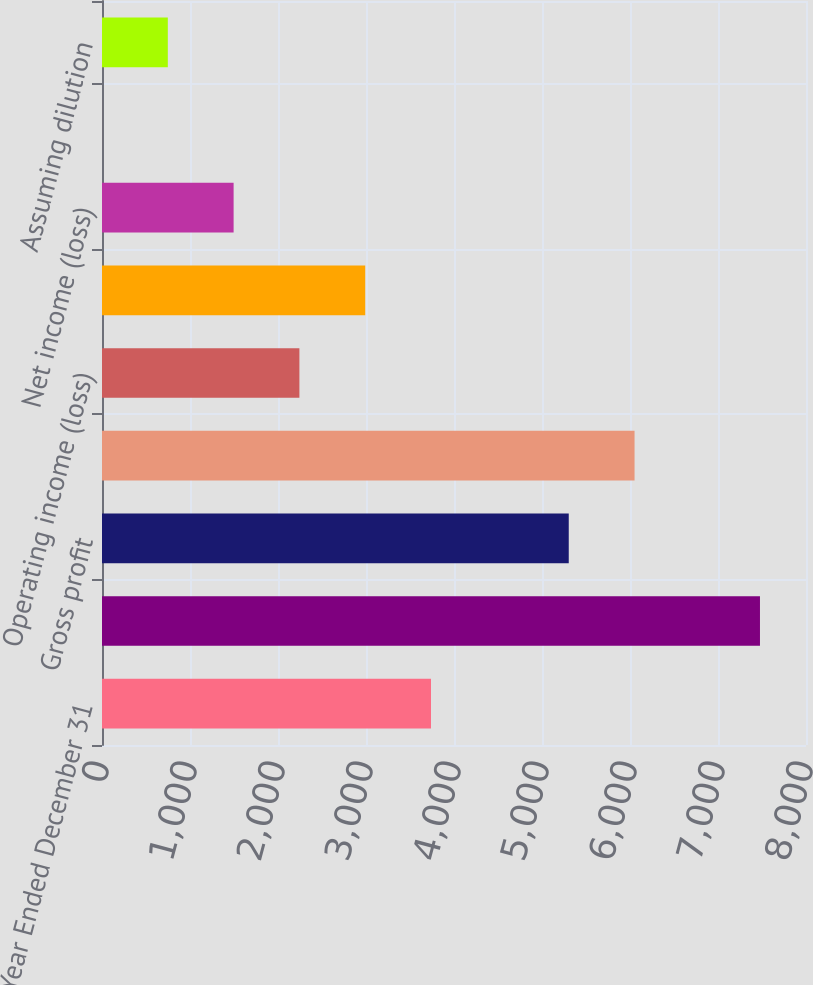<chart> <loc_0><loc_0><loc_500><loc_500><bar_chart><fcel>Year Ended December 31<fcel>Net sales<fcel>Gross profit<fcel>Total operating expenses<fcel>Operating income (loss)<fcel>Income (loss) before income<fcel>Net income (loss)<fcel>Basic<fcel>Assuming dilution<nl><fcel>3738.58<fcel>7477<fcel>5304<fcel>6051.68<fcel>2243.22<fcel>2990.9<fcel>1495.54<fcel>0.18<fcel>747.86<nl></chart> 